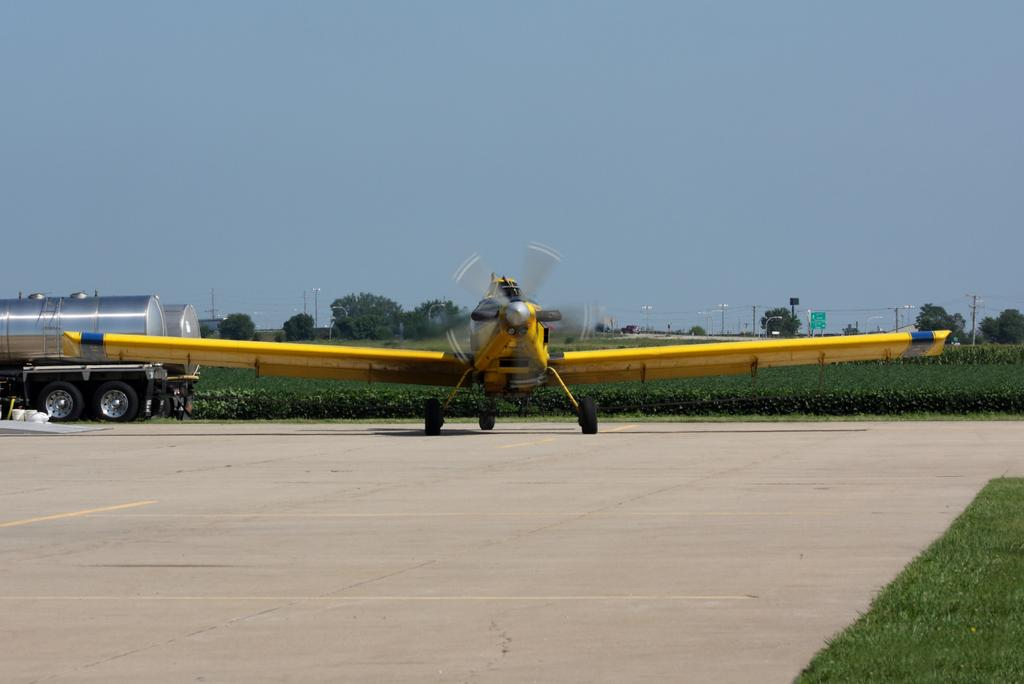What type of airplane is in the image? There is an airplane with a propeller in the image. Where is the airplane located in the image? The airplane is placed on the road. What can be seen in the background of the image? There are vehicles parked, a group of trees, poles, and the sky visible in the background of the image. What type of theory is being discussed at the event in the image? There is no event or discussion of a theory present in the image; it features an airplane on the road with various background elements. Can you tell me how many flowers are in the garden in the image? There is no garden present in the image; it features an airplane on the road with various background elements. 